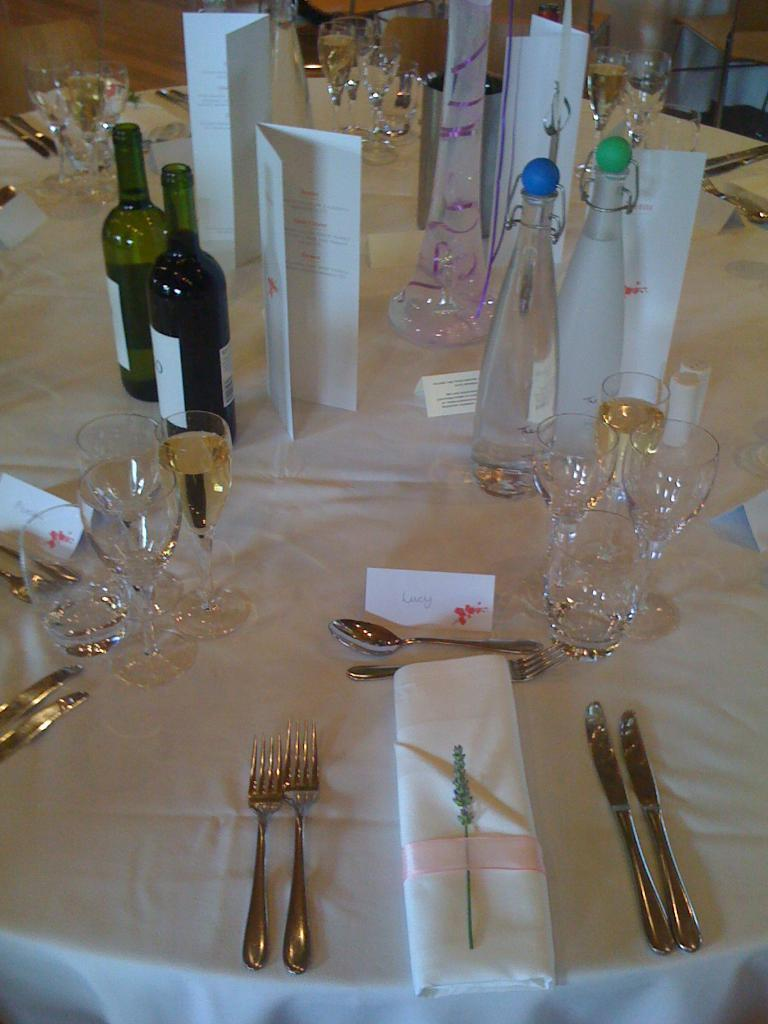What piece of furniture is present in the image? There is a table in the image. What items related to wine can be seen on the table? There are wine glasses and wine bottles on the table. What utensils are present on the table? There is a spoon and a knife on the table. What type of accessory is on the table? There is a kerchief on the table. Can you tell me how many frogs are sitting on the table in the image? There are no frogs present on the table in the image. What type of pan is being used to cook the duck in the image? There is no pan or duck present in the image; it only features a table with wine glasses, wine bottles, a spoon, a knife, and a kerchief. 